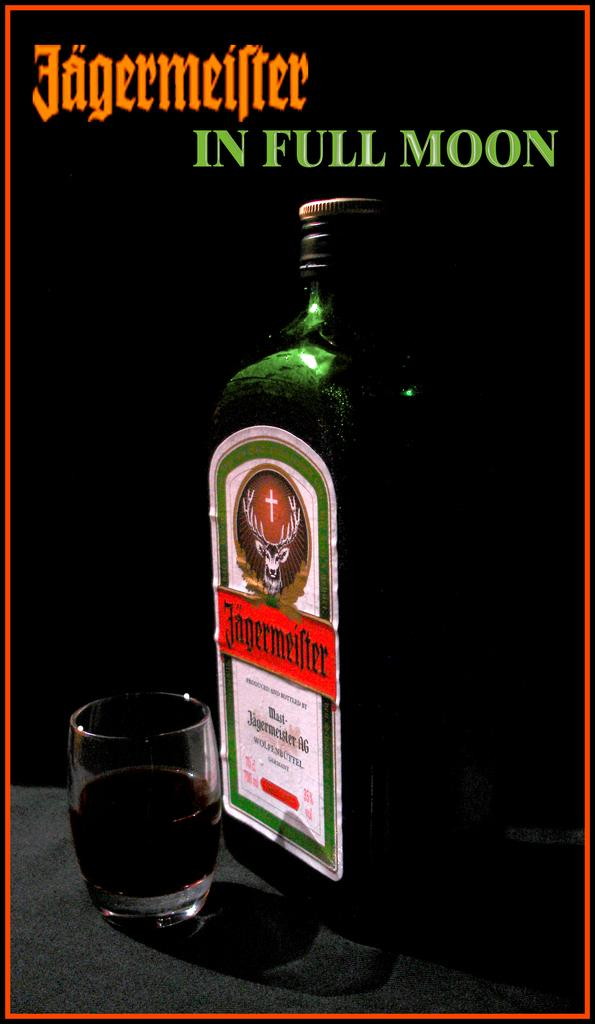<image>
Present a compact description of the photo's key features. An advertisement of Jagermeifer in Full Moon showing the bottle and a glass. 